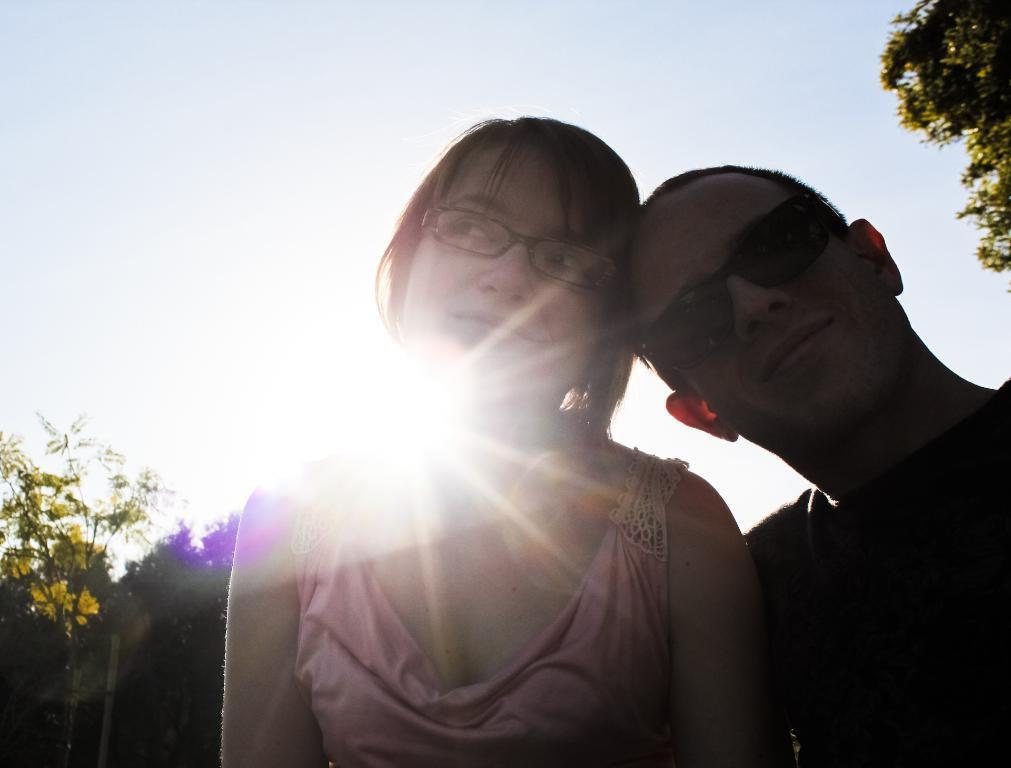How many people are in the image? There are two people in the front of the image. What can be seen in the background of the image? Trees are visible in the image. What is visible above the trees and people in the image? The sky is visible in the image. What type of line is present in the image? There is no line present in the image. What is the weather like in the image? The provided facts do not give information about the weather, so we cannot determine the weather from the image. 